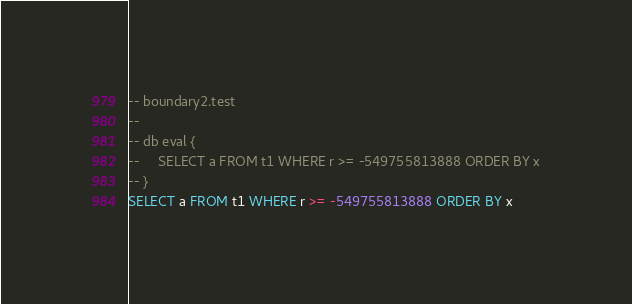Convert code to text. <code><loc_0><loc_0><loc_500><loc_500><_SQL_>-- boundary2.test
-- 
-- db eval {
--     SELECT a FROM t1 WHERE r >= -549755813888 ORDER BY x
-- }
SELECT a FROM t1 WHERE r >= -549755813888 ORDER BY x</code> 